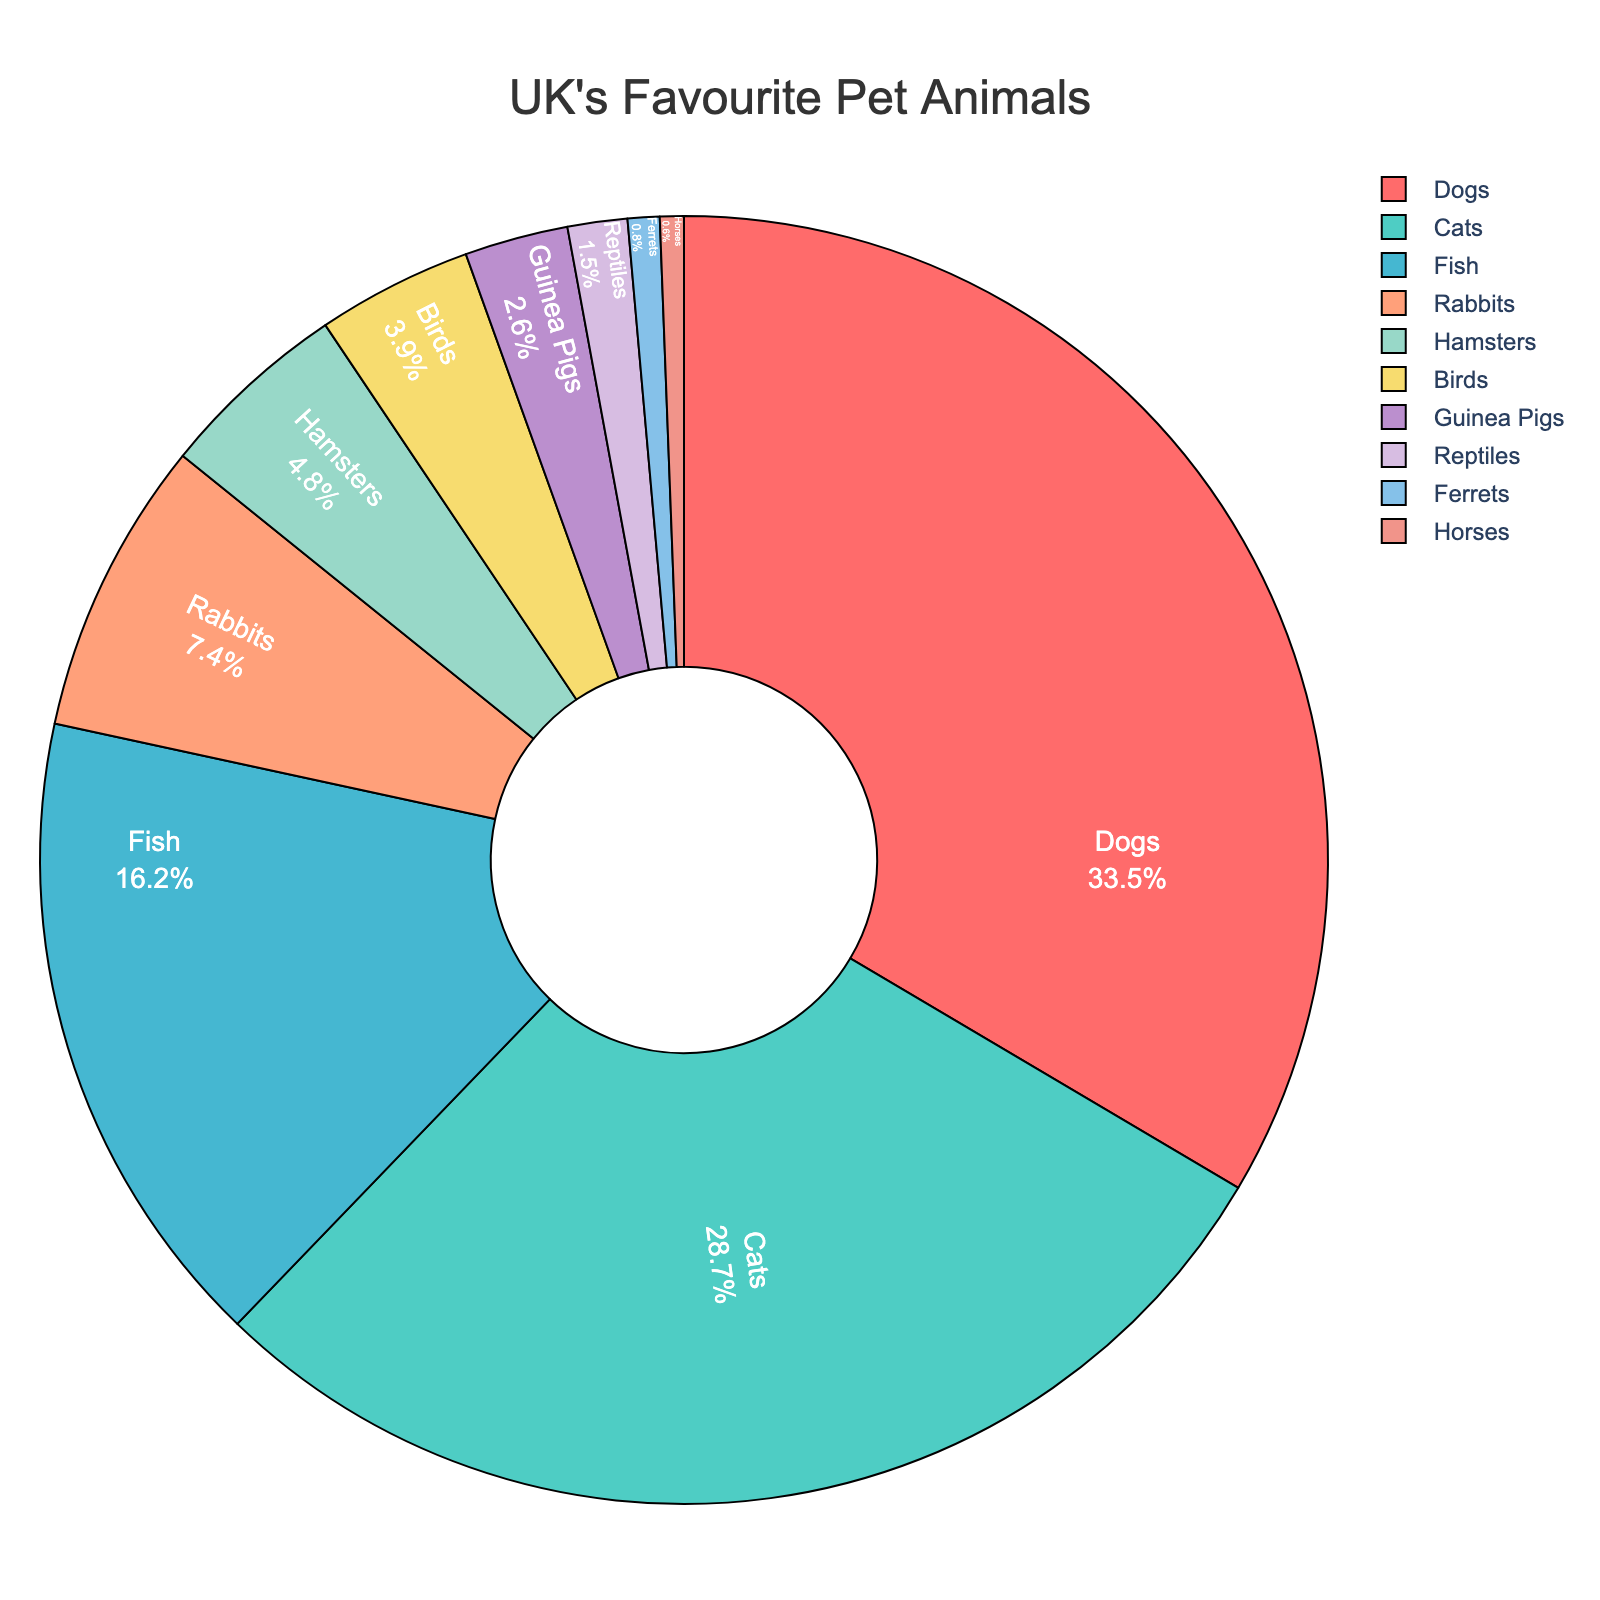What percentage of people prefer dogs or cats combined? The percentage of people who prefer dogs is 33.5% and cats is 28.7%. Adding these together: 33.5 + 28.7 = 62.2%.
Answer: 62.2% Which pet species is preferred by fewer people, hamsters or birds? The percentage of people who prefer hamsters is 4.8% and birds is 3.9%. Since 3.9% is less than 4.8%, birds are preferred by fewer people.
Answer: Birds What is the difference in percentage between the most and least preferred pet species? The most preferred species are dogs at 33.5% and the least preferred species are horses at 0.6%. The difference is 33.5 - 0.6 = 32.9%.
Answer: 32.9% Which two pet species together make up just over one-third of the total percentages? Dogs account for 33.5% and cats account for 28.7%. Adding these gives 62.2%, which is not just over one-third. Instead, we look at fish (16.2%) and cats (28.7%), which together account for 16.2 + 28.7 = 44.9%. This combination fits the criteria better.
Answer: Fish and cats What is the combined percentage of people who prefer either reptiles or ferrets? The percentage of people who prefer reptiles is 1.5% and ferrets is 0.8%. Combined, this is 1.5 + 0.8 = 2.3%.
Answer: 2.3% Which pet species is shown in red on the chart? Based on the colors specified, the species shown in red is the one with the highest percentage. Dogs account for 33.5%, the highest percentage, and should be in red.
Answer: Dogs What is the ratio of people who prefer dogs to those who prefer cats? The percentage of people who prefer dogs is 33.5% and cats is 28.7%. The ratio is 33.5 / 28.7 ≈ 1.17.
Answer: 1.17 Which pet species rank fifth in preference according to the chart? Ranked by percentage, the species are dogs, cats, fish, rabbits, and then hamsters at 4.8%. Hamsters are fifth.
Answer: Hamsters How much more popular are cats compared to rabbits? The percentage of people who prefer cats is 28.7% and rabbits is 7.4%. The difference is 28.7 - 7.4 = 21.3%.
Answer: 21.3% What's the combined percentage of people who prefer animals other than dogs, cats, and fish? Calculate the sum of the percentages for rabbits, hamsters, birds, guinea pigs, reptiles, ferrets, and horses: 7.4 + 4.8 + 3.9 + 2.6 + 1.5 + 0.8 + 0.6 = 21.6%.
Answer: 21.6% 